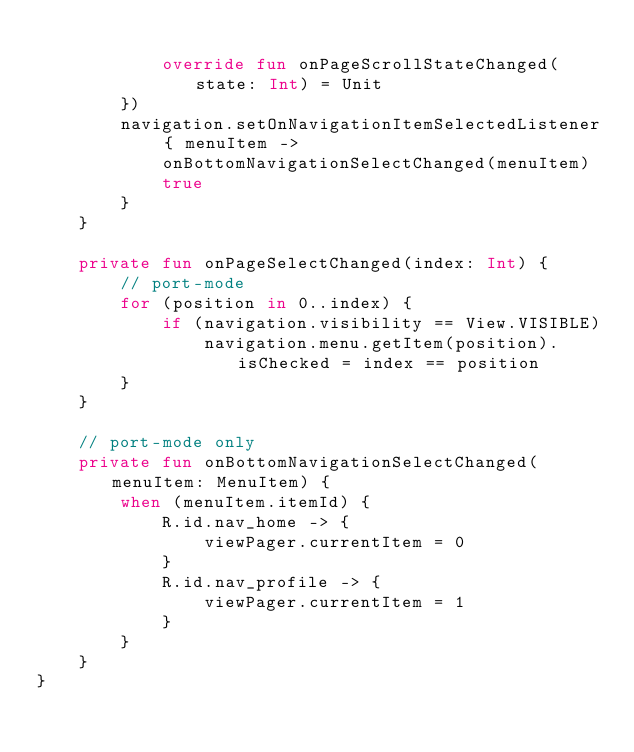<code> <loc_0><loc_0><loc_500><loc_500><_Kotlin_>
            override fun onPageScrollStateChanged(state: Int) = Unit
        })
        navigation.setOnNavigationItemSelectedListener { menuItem ->
            onBottomNavigationSelectChanged(menuItem)
            true
        }
    }

    private fun onPageSelectChanged(index: Int) {
        // port-mode
        for (position in 0..index) {
            if (navigation.visibility == View.VISIBLE)
                navigation.menu.getItem(position).isChecked = index == position
        }
    }

    // port-mode only
    private fun onBottomNavigationSelectChanged(menuItem: MenuItem) {
        when (menuItem.itemId) {
            R.id.nav_home -> {
                viewPager.currentItem = 0
            }
            R.id.nav_profile -> {
                viewPager.currentItem = 1
            }
        }
    }
}</code> 